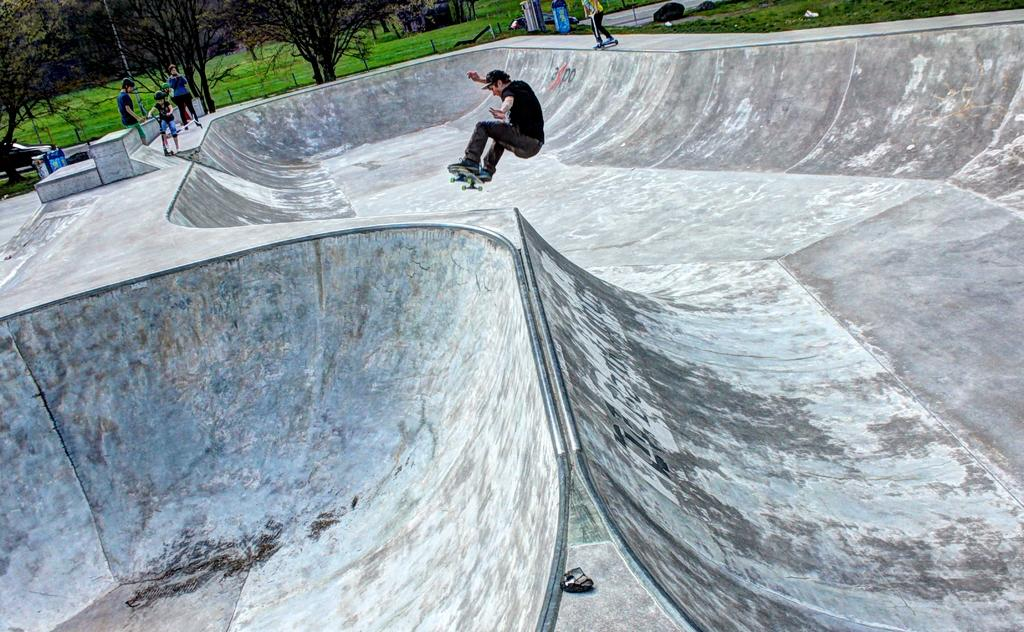What is the man in the image doing? The man is riding a skateboard in the image. What surface is the man riding on? The man is on a surface, but the specific type of surface is not mentioned in the facts. Can you describe the people in the image? The facts mention that there are people in the image, but no specific details about them are provided. What type of vegetation is present in the image? Grass is present in the image, and trees are visible as well. What other objects can be seen in the image? The facts mention that there are other objects in the image, but no specific details about them are provided. What type of jewel is the man wearing on his skateboard? There is no mention of a jewel in the image, and the man is not wearing anything on his skateboard. 